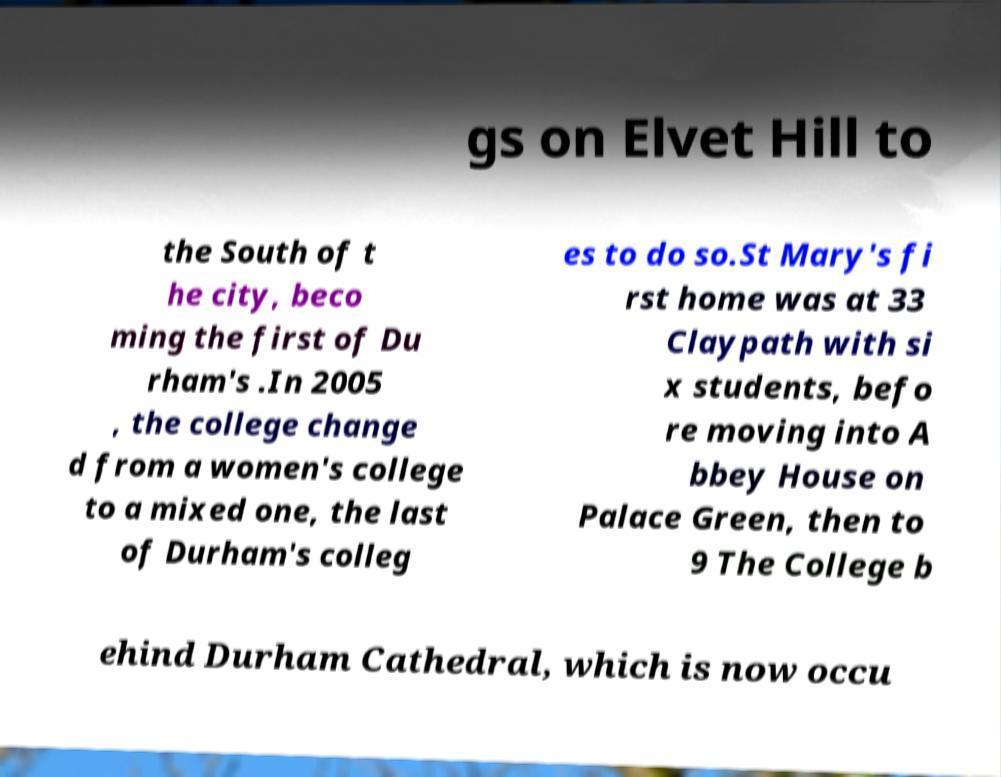Could you extract and type out the text from this image? gs on Elvet Hill to the South of t he city, beco ming the first of Du rham's .In 2005 , the college change d from a women's college to a mixed one, the last of Durham's colleg es to do so.St Mary's fi rst home was at 33 Claypath with si x students, befo re moving into A bbey House on Palace Green, then to 9 The College b ehind Durham Cathedral, which is now occu 